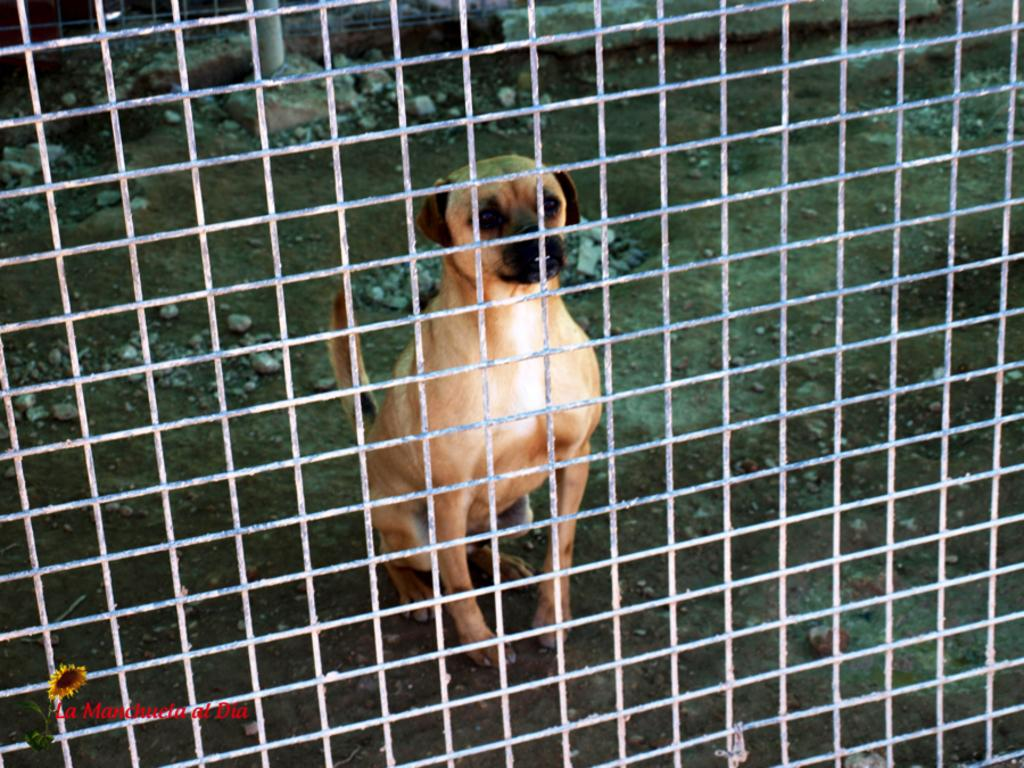What is present in the image that might be used for containing animals? There is a cage in the image. What type of animal is behind the cage? There is a dog behind the cage. What can be seen on the ground in the image? There are stones on the ground in the image. What type of taste does the jar have in the image? There is no jar present in the image, so it is not possible to determine its taste. 